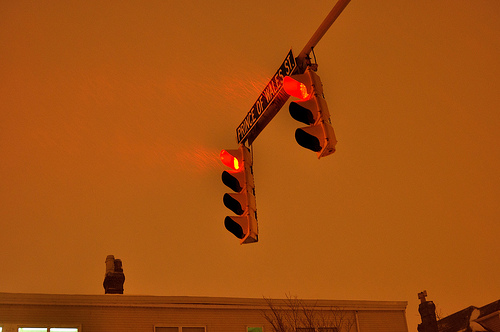<image>
Is there a sign on the pole? Yes. Looking at the image, I can see the sign is positioned on top of the pole, with the pole providing support. Is there a light on the pole? Yes. Looking at the image, I can see the light is positioned on top of the pole, with the pole providing support. 